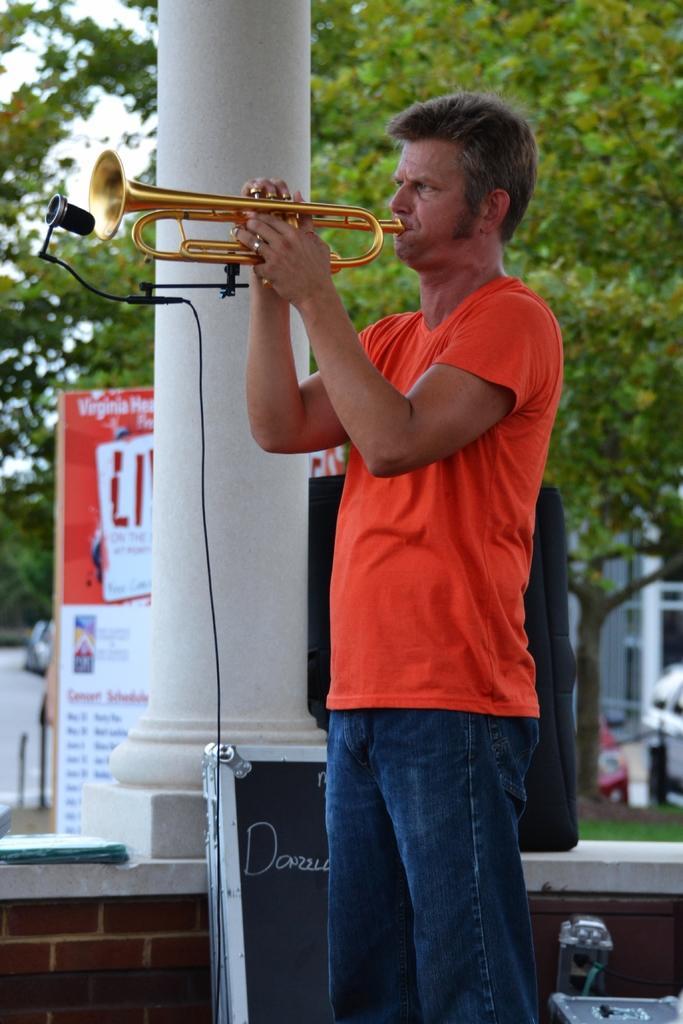Please provide a concise description of this image. In this image there is a man standing and holding a trumpet, and there is a mike with a mike stand, speaker, board, trees, sky. 